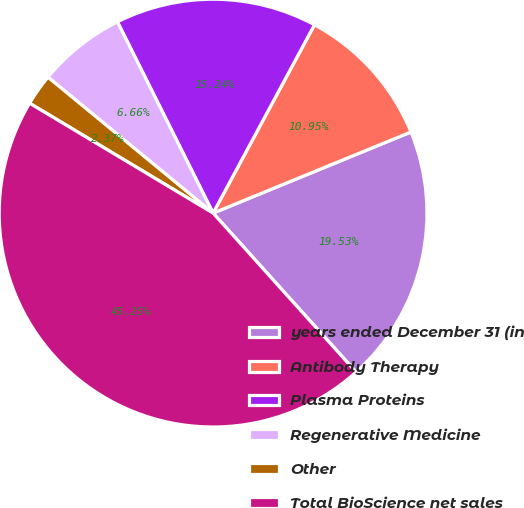<chart> <loc_0><loc_0><loc_500><loc_500><pie_chart><fcel>years ended December 31 (in<fcel>Antibody Therapy<fcel>Plasma Proteins<fcel>Regenerative Medicine<fcel>Other<fcel>Total BioScience net sales<nl><fcel>19.53%<fcel>10.95%<fcel>15.24%<fcel>6.66%<fcel>2.37%<fcel>45.25%<nl></chart> 